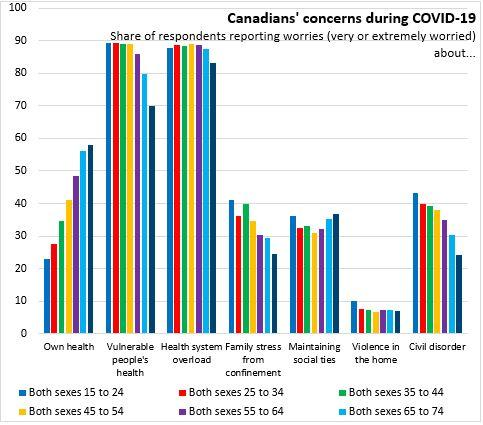Indicate a few pertinent items in this graphic. Of the respondents who are concerned about their health, those between the ages of 35 and 44 make up the largest group, with 35 being the lower boundary. There are 35 people aged 55 to 64 who are concerned about the potential civil disorder affecting both genders. 